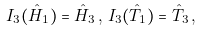Convert formula to latex. <formula><loc_0><loc_0><loc_500><loc_500>I _ { 3 } ( \hat { H } _ { 1 } ) = \hat { H } _ { 3 } \, , \, I _ { 3 } ( \hat { T } _ { 1 } ) = \hat { T } _ { 3 } \, ,</formula> 